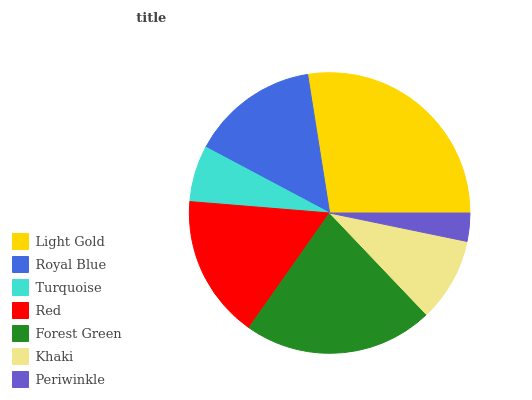Is Periwinkle the minimum?
Answer yes or no. Yes. Is Light Gold the maximum?
Answer yes or no. Yes. Is Royal Blue the minimum?
Answer yes or no. No. Is Royal Blue the maximum?
Answer yes or no. No. Is Light Gold greater than Royal Blue?
Answer yes or no. Yes. Is Royal Blue less than Light Gold?
Answer yes or no. Yes. Is Royal Blue greater than Light Gold?
Answer yes or no. No. Is Light Gold less than Royal Blue?
Answer yes or no. No. Is Royal Blue the high median?
Answer yes or no. Yes. Is Royal Blue the low median?
Answer yes or no. Yes. Is Khaki the high median?
Answer yes or no. No. Is Turquoise the low median?
Answer yes or no. No. 